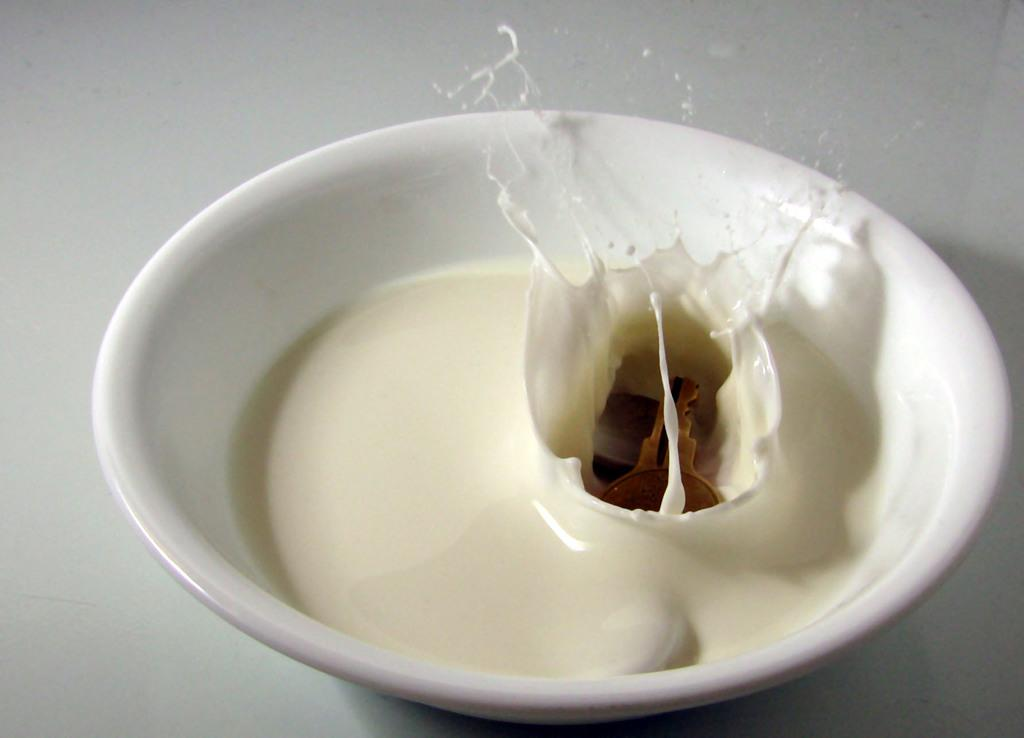What is in the bowl that is visible in the picture? The bowl contains milk. Is there anything else in the bowl besides milk? Yes, there is a key in the bowl. What is the color of the background in the image? The background of the image is white. Are there any bushes visible in the image? No, there are no bushes present in the image. Is there a baseball game happening in the background of the image? No, there is no baseball game or any reference to sports in the image. 